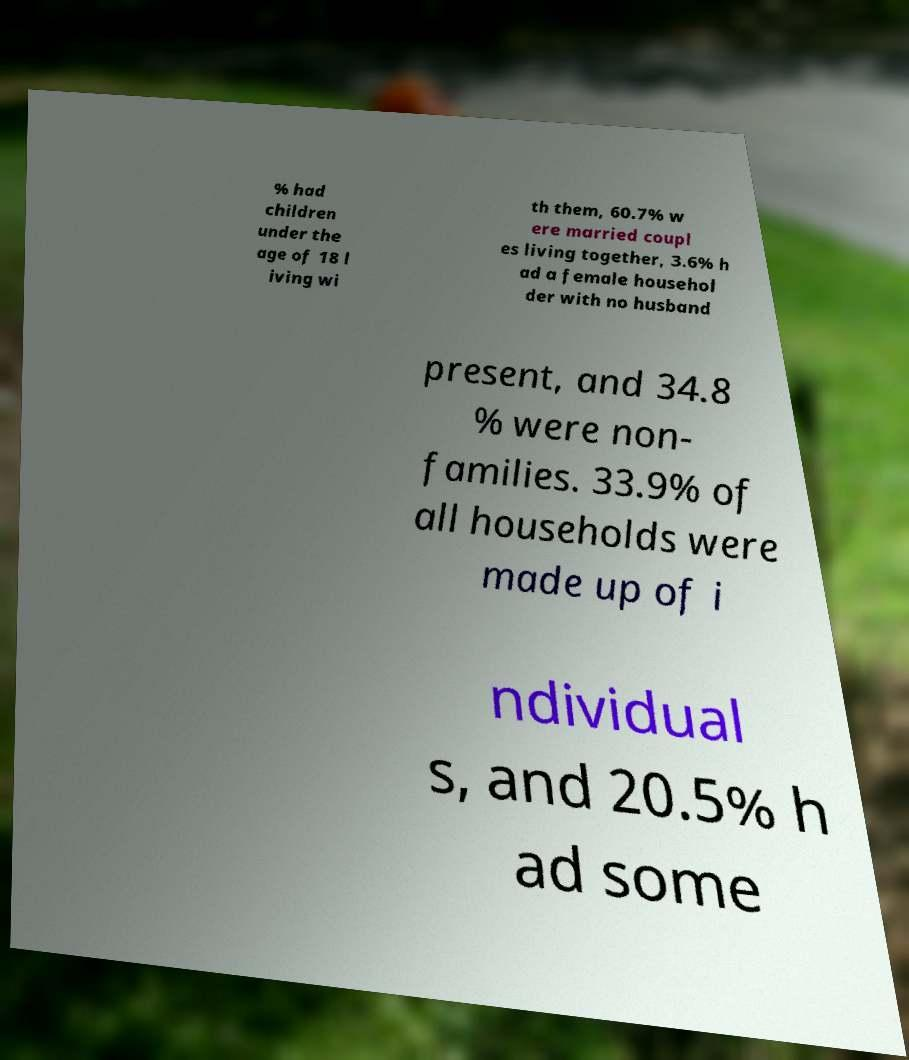There's text embedded in this image that I need extracted. Can you transcribe it verbatim? % had children under the age of 18 l iving wi th them, 60.7% w ere married coupl es living together, 3.6% h ad a female househol der with no husband present, and 34.8 % were non- families. 33.9% of all households were made up of i ndividual s, and 20.5% h ad some 